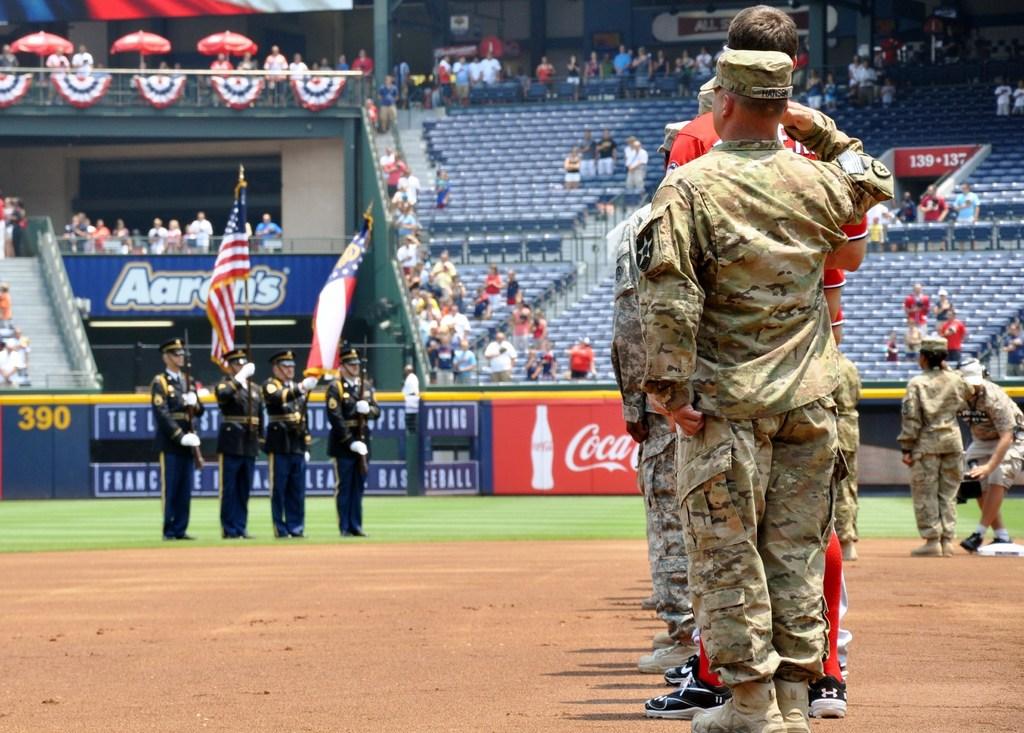What soft drink brand is on the wall?
Offer a terse response. Coca-cola. What's on the blue banner behindthe flags?
Keep it short and to the point. Aaron's. 